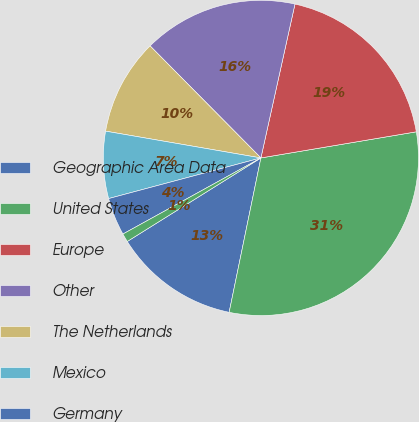Convert chart to OTSL. <chart><loc_0><loc_0><loc_500><loc_500><pie_chart><fcel>Geographic Area Data<fcel>United States<fcel>Europe<fcel>Other<fcel>The Netherlands<fcel>Mexico<fcel>Germany<fcel>United Kingdom<nl><fcel>12.88%<fcel>30.88%<fcel>18.88%<fcel>15.88%<fcel>9.87%<fcel>6.87%<fcel>3.87%<fcel>0.87%<nl></chart> 